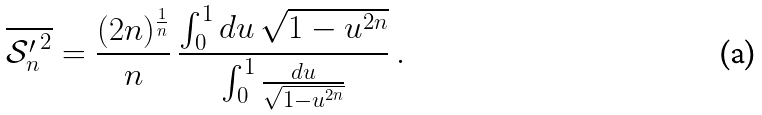<formula> <loc_0><loc_0><loc_500><loc_500>\overline { { { \mathcal { S } } _ { n } ^ { \prime } } ^ { 2 } } = \frac { ( 2 n ) ^ { \frac { 1 } { n } } } { n } \, \frac { \int _ { 0 } ^ { 1 } d u \, \sqrt { 1 - u ^ { 2 n } } } { \int _ { 0 } ^ { 1 } \frac { d u } { \sqrt { 1 - u ^ { 2 n } } } } \, .</formula> 